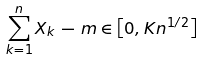Convert formula to latex. <formula><loc_0><loc_0><loc_500><loc_500>\sum _ { k = 1 } ^ { n } X _ { k } \, - \, m \in \left [ 0 , K n ^ { 1 / 2 } \right ]</formula> 